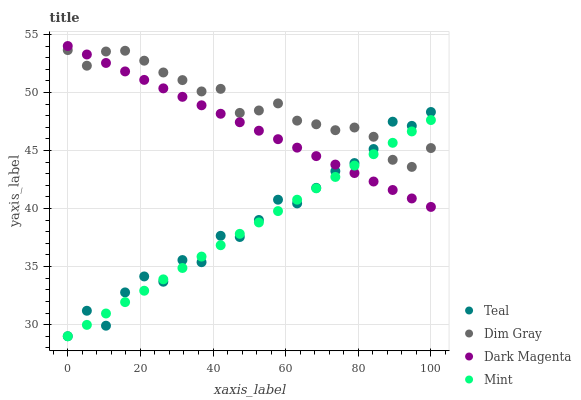Does Mint have the minimum area under the curve?
Answer yes or no. Yes. Does Dim Gray have the maximum area under the curve?
Answer yes or no. Yes. Does Dark Magenta have the minimum area under the curve?
Answer yes or no. No. Does Dark Magenta have the maximum area under the curve?
Answer yes or no. No. Is Mint the smoothest?
Answer yes or no. Yes. Is Teal the roughest?
Answer yes or no. Yes. Is Dark Magenta the smoothest?
Answer yes or no. No. Is Dark Magenta the roughest?
Answer yes or no. No. Does Mint have the lowest value?
Answer yes or no. Yes. Does Dark Magenta have the lowest value?
Answer yes or no. No. Does Dark Magenta have the highest value?
Answer yes or no. Yes. Does Mint have the highest value?
Answer yes or no. No. Does Dark Magenta intersect Dim Gray?
Answer yes or no. Yes. Is Dark Magenta less than Dim Gray?
Answer yes or no. No. Is Dark Magenta greater than Dim Gray?
Answer yes or no. No. 